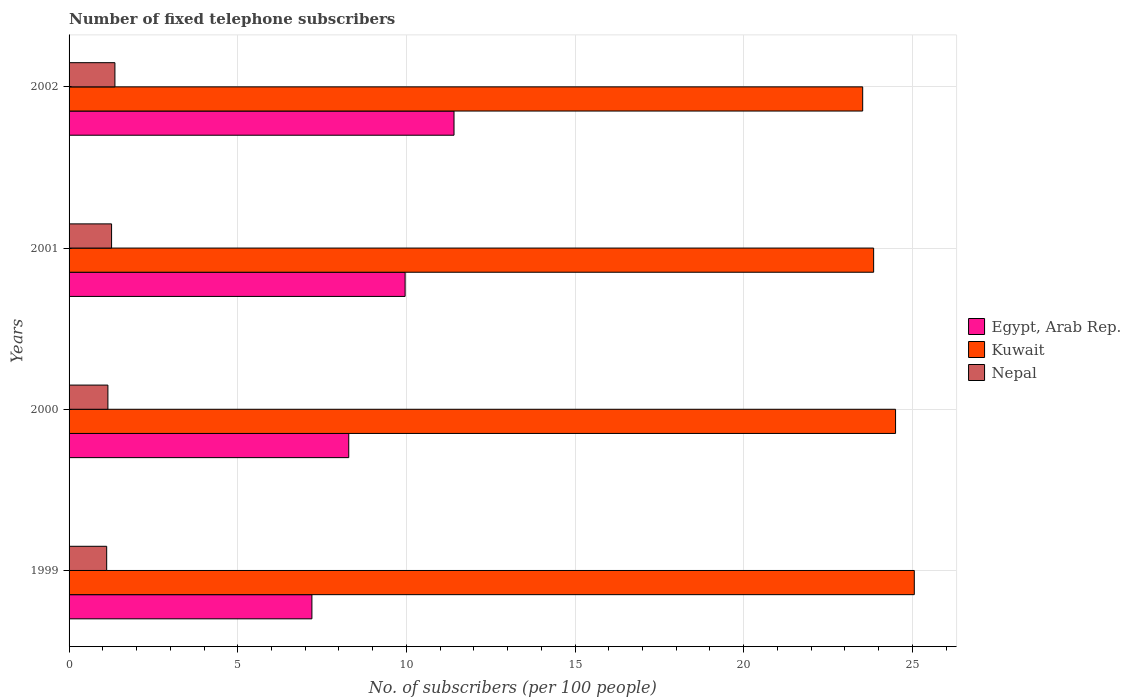How many different coloured bars are there?
Your answer should be compact. 3. Are the number of bars per tick equal to the number of legend labels?
Make the answer very short. Yes. Are the number of bars on each tick of the Y-axis equal?
Make the answer very short. Yes. How many bars are there on the 3rd tick from the bottom?
Offer a terse response. 3. What is the label of the 1st group of bars from the top?
Keep it short and to the point. 2002. In how many cases, is the number of bars for a given year not equal to the number of legend labels?
Make the answer very short. 0. What is the number of fixed telephone subscribers in Kuwait in 1999?
Make the answer very short. 25.06. Across all years, what is the maximum number of fixed telephone subscribers in Kuwait?
Keep it short and to the point. 25.06. Across all years, what is the minimum number of fixed telephone subscribers in Nepal?
Your response must be concise. 1.12. In which year was the number of fixed telephone subscribers in Nepal minimum?
Provide a short and direct response. 1999. What is the total number of fixed telephone subscribers in Nepal in the graph?
Ensure brevity in your answer.  4.89. What is the difference between the number of fixed telephone subscribers in Kuwait in 1999 and that in 2001?
Provide a short and direct response. 1.21. What is the difference between the number of fixed telephone subscribers in Egypt, Arab Rep. in 2000 and the number of fixed telephone subscribers in Nepal in 2001?
Your response must be concise. 7.03. What is the average number of fixed telephone subscribers in Nepal per year?
Keep it short and to the point. 1.22. In the year 1999, what is the difference between the number of fixed telephone subscribers in Nepal and number of fixed telephone subscribers in Kuwait?
Make the answer very short. -23.94. What is the ratio of the number of fixed telephone subscribers in Kuwait in 2000 to that in 2002?
Provide a short and direct response. 1.04. Is the number of fixed telephone subscribers in Egypt, Arab Rep. in 2001 less than that in 2002?
Ensure brevity in your answer.  Yes. What is the difference between the highest and the second highest number of fixed telephone subscribers in Egypt, Arab Rep.?
Your answer should be compact. 1.45. What is the difference between the highest and the lowest number of fixed telephone subscribers in Nepal?
Keep it short and to the point. 0.24. Is the sum of the number of fixed telephone subscribers in Kuwait in 1999 and 2002 greater than the maximum number of fixed telephone subscribers in Nepal across all years?
Your answer should be very brief. Yes. What does the 3rd bar from the top in 2002 represents?
Give a very brief answer. Egypt, Arab Rep. What does the 2nd bar from the bottom in 1999 represents?
Your answer should be very brief. Kuwait. Is it the case that in every year, the sum of the number of fixed telephone subscribers in Nepal and number of fixed telephone subscribers in Egypt, Arab Rep. is greater than the number of fixed telephone subscribers in Kuwait?
Offer a terse response. No. How many bars are there?
Ensure brevity in your answer.  12. Are all the bars in the graph horizontal?
Provide a short and direct response. Yes. How many years are there in the graph?
Make the answer very short. 4. Does the graph contain any zero values?
Ensure brevity in your answer.  No. Does the graph contain grids?
Your answer should be compact. Yes. Where does the legend appear in the graph?
Keep it short and to the point. Center right. What is the title of the graph?
Make the answer very short. Number of fixed telephone subscribers. What is the label or title of the X-axis?
Provide a short and direct response. No. of subscribers (per 100 people). What is the No. of subscribers (per 100 people) in Egypt, Arab Rep. in 1999?
Offer a very short reply. 7.2. What is the No. of subscribers (per 100 people) of Kuwait in 1999?
Keep it short and to the point. 25.06. What is the No. of subscribers (per 100 people) of Nepal in 1999?
Offer a terse response. 1.12. What is the No. of subscribers (per 100 people) in Egypt, Arab Rep. in 2000?
Ensure brevity in your answer.  8.29. What is the No. of subscribers (per 100 people) in Kuwait in 2000?
Ensure brevity in your answer.  24.5. What is the No. of subscribers (per 100 people) in Nepal in 2000?
Make the answer very short. 1.15. What is the No. of subscribers (per 100 people) of Egypt, Arab Rep. in 2001?
Your answer should be very brief. 9.96. What is the No. of subscribers (per 100 people) of Kuwait in 2001?
Provide a succinct answer. 23.85. What is the No. of subscribers (per 100 people) in Nepal in 2001?
Your response must be concise. 1.26. What is the No. of subscribers (per 100 people) of Egypt, Arab Rep. in 2002?
Your answer should be very brief. 11.41. What is the No. of subscribers (per 100 people) of Kuwait in 2002?
Ensure brevity in your answer.  23.53. What is the No. of subscribers (per 100 people) of Nepal in 2002?
Your answer should be very brief. 1.36. Across all years, what is the maximum No. of subscribers (per 100 people) in Egypt, Arab Rep.?
Make the answer very short. 11.41. Across all years, what is the maximum No. of subscribers (per 100 people) in Kuwait?
Offer a terse response. 25.06. Across all years, what is the maximum No. of subscribers (per 100 people) of Nepal?
Your answer should be compact. 1.36. Across all years, what is the minimum No. of subscribers (per 100 people) in Egypt, Arab Rep.?
Keep it short and to the point. 7.2. Across all years, what is the minimum No. of subscribers (per 100 people) in Kuwait?
Make the answer very short. 23.53. Across all years, what is the minimum No. of subscribers (per 100 people) of Nepal?
Keep it short and to the point. 1.12. What is the total No. of subscribers (per 100 people) in Egypt, Arab Rep. in the graph?
Offer a very short reply. 36.86. What is the total No. of subscribers (per 100 people) of Kuwait in the graph?
Offer a terse response. 96.94. What is the total No. of subscribers (per 100 people) in Nepal in the graph?
Keep it short and to the point. 4.89. What is the difference between the No. of subscribers (per 100 people) of Egypt, Arab Rep. in 1999 and that in 2000?
Offer a very short reply. -1.09. What is the difference between the No. of subscribers (per 100 people) of Kuwait in 1999 and that in 2000?
Offer a very short reply. 0.56. What is the difference between the No. of subscribers (per 100 people) in Nepal in 1999 and that in 2000?
Your answer should be compact. -0.04. What is the difference between the No. of subscribers (per 100 people) in Egypt, Arab Rep. in 1999 and that in 2001?
Provide a succinct answer. -2.76. What is the difference between the No. of subscribers (per 100 people) in Kuwait in 1999 and that in 2001?
Your answer should be compact. 1.21. What is the difference between the No. of subscribers (per 100 people) of Nepal in 1999 and that in 2001?
Make the answer very short. -0.14. What is the difference between the No. of subscribers (per 100 people) of Egypt, Arab Rep. in 1999 and that in 2002?
Give a very brief answer. -4.21. What is the difference between the No. of subscribers (per 100 people) of Kuwait in 1999 and that in 2002?
Provide a succinct answer. 1.53. What is the difference between the No. of subscribers (per 100 people) of Nepal in 1999 and that in 2002?
Your answer should be compact. -0.24. What is the difference between the No. of subscribers (per 100 people) of Egypt, Arab Rep. in 2000 and that in 2001?
Provide a short and direct response. -1.67. What is the difference between the No. of subscribers (per 100 people) in Kuwait in 2000 and that in 2001?
Your answer should be compact. 0.65. What is the difference between the No. of subscribers (per 100 people) of Nepal in 2000 and that in 2001?
Make the answer very short. -0.11. What is the difference between the No. of subscribers (per 100 people) of Egypt, Arab Rep. in 2000 and that in 2002?
Give a very brief answer. -3.12. What is the difference between the No. of subscribers (per 100 people) of Nepal in 2000 and that in 2002?
Your answer should be very brief. -0.21. What is the difference between the No. of subscribers (per 100 people) in Egypt, Arab Rep. in 2001 and that in 2002?
Keep it short and to the point. -1.45. What is the difference between the No. of subscribers (per 100 people) of Kuwait in 2001 and that in 2002?
Give a very brief answer. 0.32. What is the difference between the No. of subscribers (per 100 people) of Nepal in 2001 and that in 2002?
Provide a short and direct response. -0.1. What is the difference between the No. of subscribers (per 100 people) in Egypt, Arab Rep. in 1999 and the No. of subscribers (per 100 people) in Kuwait in 2000?
Ensure brevity in your answer.  -17.3. What is the difference between the No. of subscribers (per 100 people) in Egypt, Arab Rep. in 1999 and the No. of subscribers (per 100 people) in Nepal in 2000?
Offer a terse response. 6.05. What is the difference between the No. of subscribers (per 100 people) in Kuwait in 1999 and the No. of subscribers (per 100 people) in Nepal in 2000?
Your answer should be compact. 23.91. What is the difference between the No. of subscribers (per 100 people) of Egypt, Arab Rep. in 1999 and the No. of subscribers (per 100 people) of Kuwait in 2001?
Make the answer very short. -16.65. What is the difference between the No. of subscribers (per 100 people) of Egypt, Arab Rep. in 1999 and the No. of subscribers (per 100 people) of Nepal in 2001?
Your answer should be compact. 5.94. What is the difference between the No. of subscribers (per 100 people) in Kuwait in 1999 and the No. of subscribers (per 100 people) in Nepal in 2001?
Give a very brief answer. 23.8. What is the difference between the No. of subscribers (per 100 people) in Egypt, Arab Rep. in 1999 and the No. of subscribers (per 100 people) in Kuwait in 2002?
Provide a succinct answer. -16.33. What is the difference between the No. of subscribers (per 100 people) of Egypt, Arab Rep. in 1999 and the No. of subscribers (per 100 people) of Nepal in 2002?
Offer a very short reply. 5.84. What is the difference between the No. of subscribers (per 100 people) of Kuwait in 1999 and the No. of subscribers (per 100 people) of Nepal in 2002?
Offer a very short reply. 23.7. What is the difference between the No. of subscribers (per 100 people) in Egypt, Arab Rep. in 2000 and the No. of subscribers (per 100 people) in Kuwait in 2001?
Offer a terse response. -15.56. What is the difference between the No. of subscribers (per 100 people) in Egypt, Arab Rep. in 2000 and the No. of subscribers (per 100 people) in Nepal in 2001?
Provide a succinct answer. 7.03. What is the difference between the No. of subscribers (per 100 people) of Kuwait in 2000 and the No. of subscribers (per 100 people) of Nepal in 2001?
Ensure brevity in your answer.  23.24. What is the difference between the No. of subscribers (per 100 people) in Egypt, Arab Rep. in 2000 and the No. of subscribers (per 100 people) in Kuwait in 2002?
Make the answer very short. -15.24. What is the difference between the No. of subscribers (per 100 people) of Egypt, Arab Rep. in 2000 and the No. of subscribers (per 100 people) of Nepal in 2002?
Ensure brevity in your answer.  6.93. What is the difference between the No. of subscribers (per 100 people) in Kuwait in 2000 and the No. of subscribers (per 100 people) in Nepal in 2002?
Your answer should be very brief. 23.14. What is the difference between the No. of subscribers (per 100 people) in Egypt, Arab Rep. in 2001 and the No. of subscribers (per 100 people) in Kuwait in 2002?
Offer a very short reply. -13.57. What is the difference between the No. of subscribers (per 100 people) of Egypt, Arab Rep. in 2001 and the No. of subscribers (per 100 people) of Nepal in 2002?
Your response must be concise. 8.6. What is the difference between the No. of subscribers (per 100 people) in Kuwait in 2001 and the No. of subscribers (per 100 people) in Nepal in 2002?
Keep it short and to the point. 22.49. What is the average No. of subscribers (per 100 people) in Egypt, Arab Rep. per year?
Give a very brief answer. 9.22. What is the average No. of subscribers (per 100 people) in Kuwait per year?
Give a very brief answer. 24.23. What is the average No. of subscribers (per 100 people) in Nepal per year?
Ensure brevity in your answer.  1.22. In the year 1999, what is the difference between the No. of subscribers (per 100 people) of Egypt, Arab Rep. and No. of subscribers (per 100 people) of Kuwait?
Make the answer very short. -17.86. In the year 1999, what is the difference between the No. of subscribers (per 100 people) in Egypt, Arab Rep. and No. of subscribers (per 100 people) in Nepal?
Your answer should be compact. 6.08. In the year 1999, what is the difference between the No. of subscribers (per 100 people) in Kuwait and No. of subscribers (per 100 people) in Nepal?
Make the answer very short. 23.94. In the year 2000, what is the difference between the No. of subscribers (per 100 people) of Egypt, Arab Rep. and No. of subscribers (per 100 people) of Kuwait?
Provide a short and direct response. -16.21. In the year 2000, what is the difference between the No. of subscribers (per 100 people) of Egypt, Arab Rep. and No. of subscribers (per 100 people) of Nepal?
Make the answer very short. 7.14. In the year 2000, what is the difference between the No. of subscribers (per 100 people) of Kuwait and No. of subscribers (per 100 people) of Nepal?
Make the answer very short. 23.35. In the year 2001, what is the difference between the No. of subscribers (per 100 people) in Egypt, Arab Rep. and No. of subscribers (per 100 people) in Kuwait?
Offer a very short reply. -13.89. In the year 2001, what is the difference between the No. of subscribers (per 100 people) in Egypt, Arab Rep. and No. of subscribers (per 100 people) in Nepal?
Provide a short and direct response. 8.7. In the year 2001, what is the difference between the No. of subscribers (per 100 people) of Kuwait and No. of subscribers (per 100 people) of Nepal?
Keep it short and to the point. 22.59. In the year 2002, what is the difference between the No. of subscribers (per 100 people) of Egypt, Arab Rep. and No. of subscribers (per 100 people) of Kuwait?
Offer a terse response. -12.12. In the year 2002, what is the difference between the No. of subscribers (per 100 people) of Egypt, Arab Rep. and No. of subscribers (per 100 people) of Nepal?
Offer a terse response. 10.05. In the year 2002, what is the difference between the No. of subscribers (per 100 people) in Kuwait and No. of subscribers (per 100 people) in Nepal?
Ensure brevity in your answer.  22.17. What is the ratio of the No. of subscribers (per 100 people) of Egypt, Arab Rep. in 1999 to that in 2000?
Your answer should be very brief. 0.87. What is the ratio of the No. of subscribers (per 100 people) in Kuwait in 1999 to that in 2000?
Your answer should be very brief. 1.02. What is the ratio of the No. of subscribers (per 100 people) in Nepal in 1999 to that in 2000?
Offer a very short reply. 0.97. What is the ratio of the No. of subscribers (per 100 people) of Egypt, Arab Rep. in 1999 to that in 2001?
Offer a very short reply. 0.72. What is the ratio of the No. of subscribers (per 100 people) in Kuwait in 1999 to that in 2001?
Your response must be concise. 1.05. What is the ratio of the No. of subscribers (per 100 people) in Nepal in 1999 to that in 2001?
Your answer should be very brief. 0.89. What is the ratio of the No. of subscribers (per 100 people) of Egypt, Arab Rep. in 1999 to that in 2002?
Provide a succinct answer. 0.63. What is the ratio of the No. of subscribers (per 100 people) in Kuwait in 1999 to that in 2002?
Your response must be concise. 1.06. What is the ratio of the No. of subscribers (per 100 people) in Nepal in 1999 to that in 2002?
Your answer should be compact. 0.82. What is the ratio of the No. of subscribers (per 100 people) of Egypt, Arab Rep. in 2000 to that in 2001?
Keep it short and to the point. 0.83. What is the ratio of the No. of subscribers (per 100 people) of Kuwait in 2000 to that in 2001?
Your response must be concise. 1.03. What is the ratio of the No. of subscribers (per 100 people) of Nepal in 2000 to that in 2001?
Provide a short and direct response. 0.91. What is the ratio of the No. of subscribers (per 100 people) of Egypt, Arab Rep. in 2000 to that in 2002?
Your answer should be very brief. 0.73. What is the ratio of the No. of subscribers (per 100 people) in Kuwait in 2000 to that in 2002?
Offer a terse response. 1.04. What is the ratio of the No. of subscribers (per 100 people) of Nepal in 2000 to that in 2002?
Make the answer very short. 0.85. What is the ratio of the No. of subscribers (per 100 people) of Egypt, Arab Rep. in 2001 to that in 2002?
Give a very brief answer. 0.87. What is the ratio of the No. of subscribers (per 100 people) of Kuwait in 2001 to that in 2002?
Your answer should be very brief. 1.01. What is the ratio of the No. of subscribers (per 100 people) of Nepal in 2001 to that in 2002?
Offer a very short reply. 0.93. What is the difference between the highest and the second highest No. of subscribers (per 100 people) of Egypt, Arab Rep.?
Make the answer very short. 1.45. What is the difference between the highest and the second highest No. of subscribers (per 100 people) in Kuwait?
Your answer should be compact. 0.56. What is the difference between the highest and the second highest No. of subscribers (per 100 people) of Nepal?
Your response must be concise. 0.1. What is the difference between the highest and the lowest No. of subscribers (per 100 people) of Egypt, Arab Rep.?
Offer a very short reply. 4.21. What is the difference between the highest and the lowest No. of subscribers (per 100 people) of Kuwait?
Your answer should be very brief. 1.53. What is the difference between the highest and the lowest No. of subscribers (per 100 people) of Nepal?
Offer a very short reply. 0.24. 